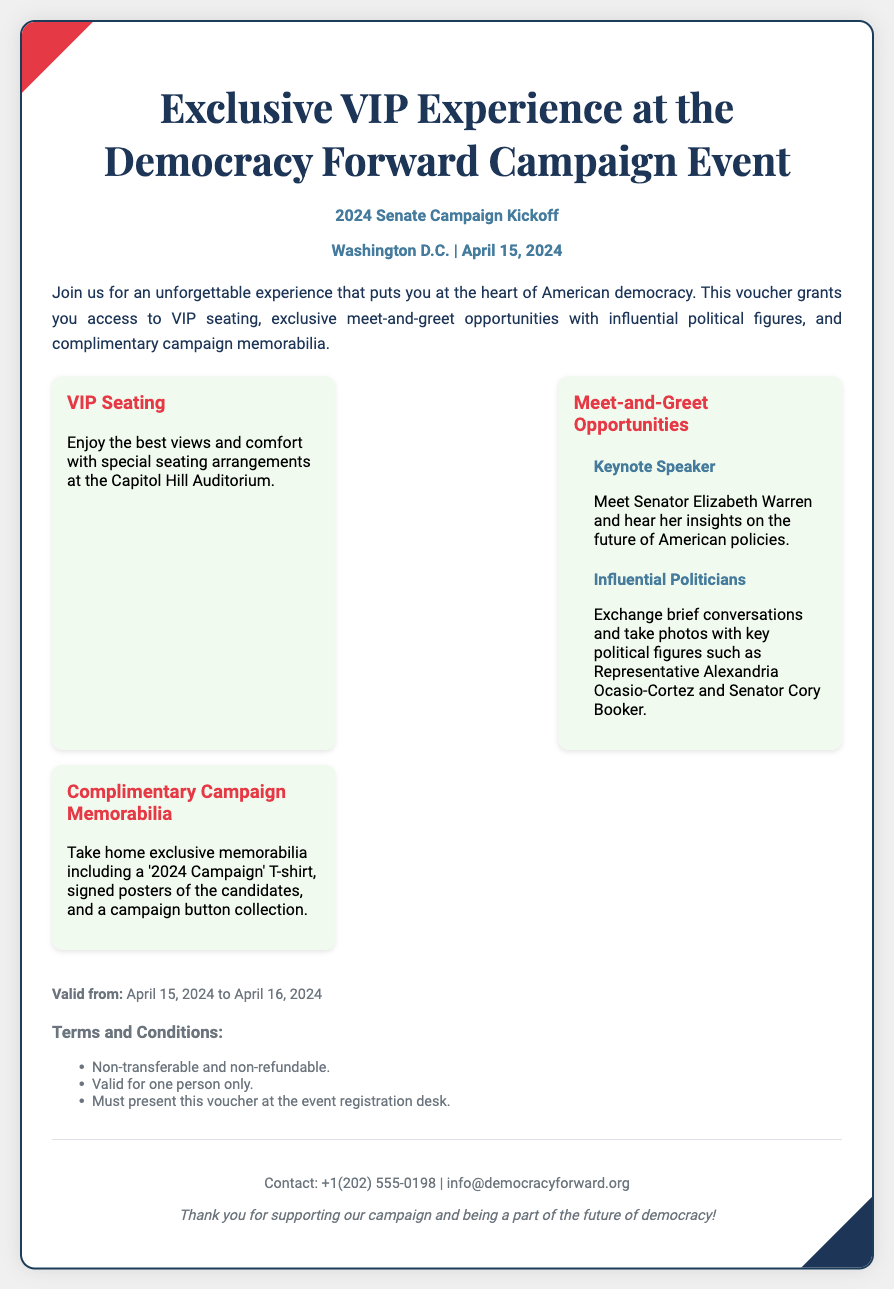What is the event title? The event title is prominently displayed at the top of the document.
Answer: Exclusive VIP Experience at the Democracy Forward Campaign Event When is the campaign event? The date of the campaign event is mentioned in the header section of the document.
Answer: April 15, 2024 Who is the keynote speaker? The name of the keynote speaker is listed under the Meet-and-Greet Opportunities section.
Answer: Senator Elizabeth Warren What type of seating is offered? The type of seating available is mentioned in the features section.
Answer: VIP Seating What complimentary items are included? The complimentary items are described under the Complimentary Campaign Memorabilia section.
Answer: '2024 Campaign' T-shirt, signed posters, and a campaign button collection What is the validity period of the voucher? The validity period is outlined in the validity section of the document.
Answer: April 15, 2024 to April 16, 2024 Is the voucher transferable? The terms regarding transferability are mentioned in the Terms and Conditions section.
Answer: Non-transferable What is the venue for the event? The venue is indicated by the location in the event details.
Answer: Capitol Hill Auditorium 